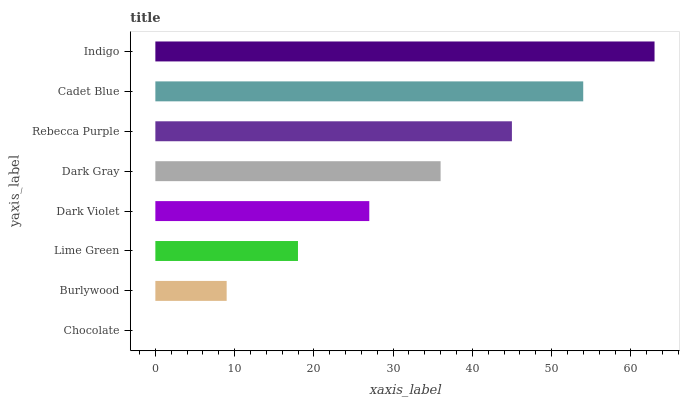Is Chocolate the minimum?
Answer yes or no. Yes. Is Indigo the maximum?
Answer yes or no. Yes. Is Burlywood the minimum?
Answer yes or no. No. Is Burlywood the maximum?
Answer yes or no. No. Is Burlywood greater than Chocolate?
Answer yes or no. Yes. Is Chocolate less than Burlywood?
Answer yes or no. Yes. Is Chocolate greater than Burlywood?
Answer yes or no. No. Is Burlywood less than Chocolate?
Answer yes or no. No. Is Dark Gray the high median?
Answer yes or no. Yes. Is Dark Violet the low median?
Answer yes or no. Yes. Is Dark Violet the high median?
Answer yes or no. No. Is Chocolate the low median?
Answer yes or no. No. 